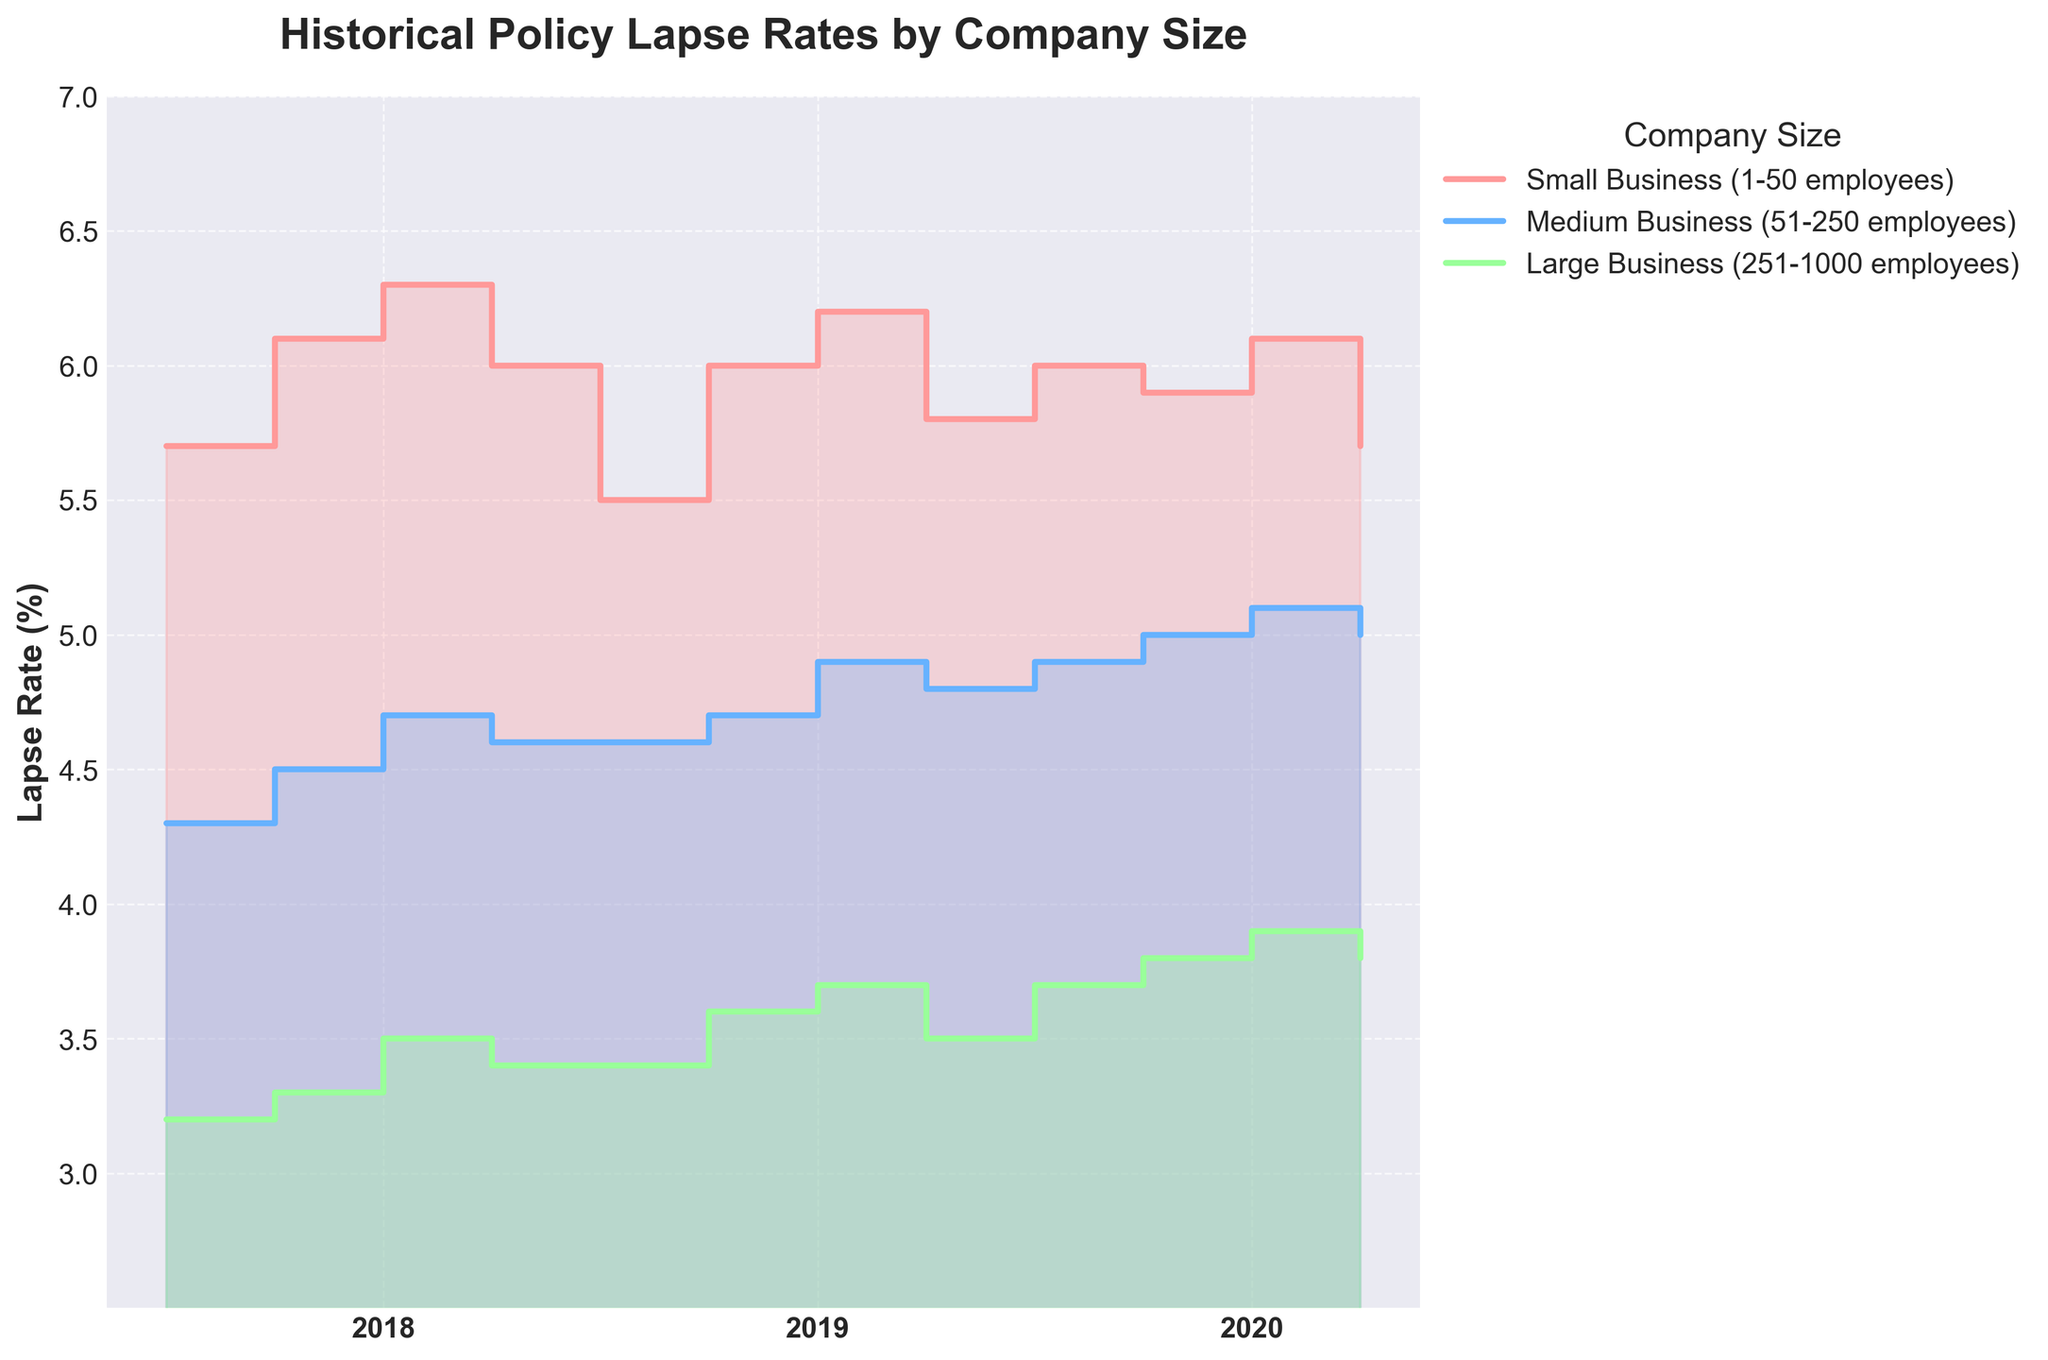What is the title of the chart? The title can be found at the top of the chart and usually describes the main focus of the data being presented. Here, it is written in large, bold letters.
Answer: Historical Policy Lapse Rates by Company Size What are the company sizes included in the chart? The company sizes are indicated in the legend on the right-hand side of the chart. Each size is associated with a specific color.
Answer: Small Business (1-50 employees), Medium Business (51-250 employees), Large Business (251-1000 employees) Which company size had the highest lapse rate in 2020? From the chart, you can visually trace the lines for each company size up to the year 2020, and the one with the highest point will represent the highest lapse rate. The color labels help with identification.
Answer: Small Business (1-50 employees) During which quarter did Medium Businesses see the highest lapse rate in 2019? Locate the line corresponding to Medium Businesses and follow it through the quarters of 2019. Identify the quarter where the line reaches its highest point.
Answer: Q4 How did the lapse rates for Large Businesses change from Q1 to Q4 in 2018? Follow the line for Large Businesses in the year 2018 across its quarters to see the trajectory. Check if the line ascends, descends, or remains steady.
Answer: Increased then slightly decreased Compare the lapse rates of Small Businesses and Medium Businesses in Q2 of 2020. Which is higher? Identify the lines for both Small Businesses and Medium Businesses for the second quarter of 2020, and compare their vertical positions on the chart.
Answer: Small Business (1-50 employees) Calculate the average lapse rate for Medium Businesses in 2018. Sum the values for the four quarters in 2018 for Medium Businesses and divide by 4.
Answer: (4.3 + 4.5 + 4.7 + 4.6) / 4 = 4.53 What was the trend in lapse rates for Small Businesses from 2018 to 2020? Examine the general movement of the Small Business line from 2018 to 2020, considering overall increases or decreases across years.
Answer: General decrease Which company size had the lowest lapse rate in Q3 of 2018? Look at the lapse rates for all company sizes in the third quarter of 2018 and identify the one with the lowest point.
Answer: Large Business (251-1000 employees) Is there any company size that saw an overall increase in lapse rates each year from 2018 to 2020? Check if any company's line consistently climbs from 2018 to 2020 without a dip.
Answer: Large Business (251-1000 employees) 